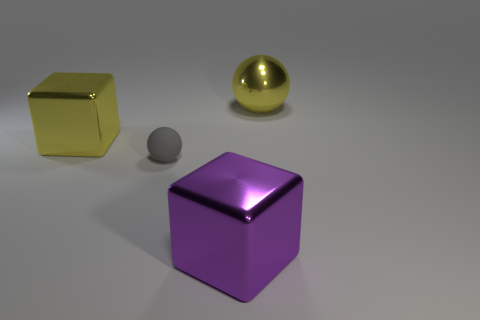Add 1 gray spheres. How many objects exist? 5 Subtract all purple cubes. How many cubes are left? 1 Add 4 big blue matte things. How many big blue matte things exist? 4 Subtract 0 cyan cylinders. How many objects are left? 4 Subtract all large yellow cylinders. Subtract all shiny balls. How many objects are left? 3 Add 3 tiny matte things. How many tiny matte things are left? 4 